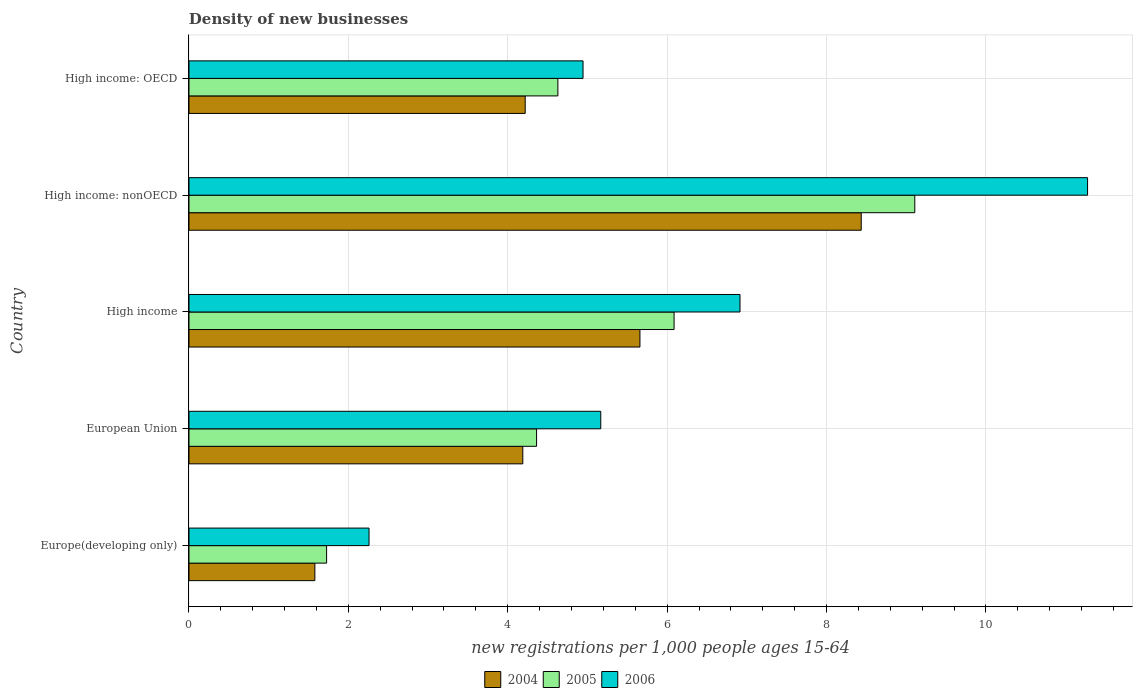How many different coloured bars are there?
Your answer should be compact. 3. Are the number of bars per tick equal to the number of legend labels?
Your answer should be very brief. Yes. Are the number of bars on each tick of the Y-axis equal?
Provide a succinct answer. Yes. What is the number of new registrations in 2006 in Europe(developing only)?
Offer a terse response. 2.26. Across all countries, what is the maximum number of new registrations in 2006?
Your response must be concise. 11.28. Across all countries, what is the minimum number of new registrations in 2005?
Your response must be concise. 1.73. In which country was the number of new registrations in 2005 maximum?
Keep it short and to the point. High income: nonOECD. In which country was the number of new registrations in 2004 minimum?
Your answer should be very brief. Europe(developing only). What is the total number of new registrations in 2005 in the graph?
Offer a terse response. 25.91. What is the difference between the number of new registrations in 2004 in High income and that in High income: OECD?
Provide a short and direct response. 1.44. What is the difference between the number of new registrations in 2004 in High income: OECD and the number of new registrations in 2006 in Europe(developing only)?
Your response must be concise. 1.96. What is the average number of new registrations in 2004 per country?
Your answer should be very brief. 4.82. What is the difference between the number of new registrations in 2005 and number of new registrations in 2004 in Europe(developing only)?
Offer a very short reply. 0.15. In how many countries, is the number of new registrations in 2006 greater than 0.8 ?
Make the answer very short. 5. What is the ratio of the number of new registrations in 2005 in European Union to that in High income?
Your answer should be very brief. 0.72. Is the number of new registrations in 2005 in Europe(developing only) less than that in European Union?
Make the answer very short. Yes. Is the difference between the number of new registrations in 2005 in High income: OECD and High income: nonOECD greater than the difference between the number of new registrations in 2004 in High income: OECD and High income: nonOECD?
Provide a succinct answer. No. What is the difference between the highest and the second highest number of new registrations in 2004?
Give a very brief answer. 2.78. What is the difference between the highest and the lowest number of new registrations in 2006?
Your answer should be very brief. 9.02. Is the sum of the number of new registrations in 2004 in High income and High income: OECD greater than the maximum number of new registrations in 2006 across all countries?
Offer a terse response. No. How many countries are there in the graph?
Your answer should be very brief. 5. What is the difference between two consecutive major ticks on the X-axis?
Ensure brevity in your answer.  2. Does the graph contain any zero values?
Offer a terse response. No. What is the title of the graph?
Give a very brief answer. Density of new businesses. Does "1971" appear as one of the legend labels in the graph?
Provide a succinct answer. No. What is the label or title of the X-axis?
Your answer should be compact. New registrations per 1,0 people ages 15-64. What is the label or title of the Y-axis?
Your response must be concise. Country. What is the new registrations per 1,000 people ages 15-64 of 2004 in Europe(developing only)?
Your answer should be very brief. 1.58. What is the new registrations per 1,000 people ages 15-64 in 2005 in Europe(developing only)?
Your response must be concise. 1.73. What is the new registrations per 1,000 people ages 15-64 of 2006 in Europe(developing only)?
Your answer should be compact. 2.26. What is the new registrations per 1,000 people ages 15-64 of 2004 in European Union?
Provide a short and direct response. 4.19. What is the new registrations per 1,000 people ages 15-64 of 2005 in European Union?
Ensure brevity in your answer.  4.36. What is the new registrations per 1,000 people ages 15-64 in 2006 in European Union?
Make the answer very short. 5.17. What is the new registrations per 1,000 people ages 15-64 of 2004 in High income?
Your answer should be compact. 5.66. What is the new registrations per 1,000 people ages 15-64 in 2005 in High income?
Provide a succinct answer. 6.09. What is the new registrations per 1,000 people ages 15-64 of 2006 in High income?
Your answer should be very brief. 6.91. What is the new registrations per 1,000 people ages 15-64 in 2004 in High income: nonOECD?
Offer a terse response. 8.44. What is the new registrations per 1,000 people ages 15-64 of 2005 in High income: nonOECD?
Give a very brief answer. 9.11. What is the new registrations per 1,000 people ages 15-64 of 2006 in High income: nonOECD?
Make the answer very short. 11.28. What is the new registrations per 1,000 people ages 15-64 of 2004 in High income: OECD?
Provide a succinct answer. 4.22. What is the new registrations per 1,000 people ages 15-64 in 2005 in High income: OECD?
Give a very brief answer. 4.63. What is the new registrations per 1,000 people ages 15-64 of 2006 in High income: OECD?
Your answer should be compact. 4.94. Across all countries, what is the maximum new registrations per 1,000 people ages 15-64 in 2004?
Offer a terse response. 8.44. Across all countries, what is the maximum new registrations per 1,000 people ages 15-64 of 2005?
Make the answer very short. 9.11. Across all countries, what is the maximum new registrations per 1,000 people ages 15-64 in 2006?
Give a very brief answer. 11.28. Across all countries, what is the minimum new registrations per 1,000 people ages 15-64 of 2004?
Offer a terse response. 1.58. Across all countries, what is the minimum new registrations per 1,000 people ages 15-64 in 2005?
Make the answer very short. 1.73. Across all countries, what is the minimum new registrations per 1,000 people ages 15-64 of 2006?
Offer a terse response. 2.26. What is the total new registrations per 1,000 people ages 15-64 of 2004 in the graph?
Give a very brief answer. 24.08. What is the total new registrations per 1,000 people ages 15-64 of 2005 in the graph?
Provide a succinct answer. 25.91. What is the total new registrations per 1,000 people ages 15-64 in 2006 in the graph?
Give a very brief answer. 30.56. What is the difference between the new registrations per 1,000 people ages 15-64 of 2004 in Europe(developing only) and that in European Union?
Give a very brief answer. -2.61. What is the difference between the new registrations per 1,000 people ages 15-64 of 2005 in Europe(developing only) and that in European Union?
Provide a short and direct response. -2.64. What is the difference between the new registrations per 1,000 people ages 15-64 of 2006 in Europe(developing only) and that in European Union?
Give a very brief answer. -2.91. What is the difference between the new registrations per 1,000 people ages 15-64 in 2004 in Europe(developing only) and that in High income?
Provide a succinct answer. -4.08. What is the difference between the new registrations per 1,000 people ages 15-64 in 2005 in Europe(developing only) and that in High income?
Provide a short and direct response. -4.36. What is the difference between the new registrations per 1,000 people ages 15-64 in 2006 in Europe(developing only) and that in High income?
Make the answer very short. -4.66. What is the difference between the new registrations per 1,000 people ages 15-64 in 2004 in Europe(developing only) and that in High income: nonOECD?
Your response must be concise. -6.86. What is the difference between the new registrations per 1,000 people ages 15-64 in 2005 in Europe(developing only) and that in High income: nonOECD?
Give a very brief answer. -7.38. What is the difference between the new registrations per 1,000 people ages 15-64 in 2006 in Europe(developing only) and that in High income: nonOECD?
Ensure brevity in your answer.  -9.02. What is the difference between the new registrations per 1,000 people ages 15-64 of 2004 in Europe(developing only) and that in High income: OECD?
Offer a very short reply. -2.64. What is the difference between the new registrations per 1,000 people ages 15-64 of 2005 in Europe(developing only) and that in High income: OECD?
Make the answer very short. -2.9. What is the difference between the new registrations per 1,000 people ages 15-64 of 2006 in Europe(developing only) and that in High income: OECD?
Your answer should be compact. -2.69. What is the difference between the new registrations per 1,000 people ages 15-64 of 2004 in European Union and that in High income?
Make the answer very short. -1.47. What is the difference between the new registrations per 1,000 people ages 15-64 of 2005 in European Union and that in High income?
Make the answer very short. -1.73. What is the difference between the new registrations per 1,000 people ages 15-64 of 2006 in European Union and that in High income?
Your response must be concise. -1.75. What is the difference between the new registrations per 1,000 people ages 15-64 in 2004 in European Union and that in High income: nonOECD?
Give a very brief answer. -4.25. What is the difference between the new registrations per 1,000 people ages 15-64 of 2005 in European Union and that in High income: nonOECD?
Your answer should be compact. -4.75. What is the difference between the new registrations per 1,000 people ages 15-64 of 2006 in European Union and that in High income: nonOECD?
Offer a terse response. -6.11. What is the difference between the new registrations per 1,000 people ages 15-64 in 2004 in European Union and that in High income: OECD?
Make the answer very short. -0.03. What is the difference between the new registrations per 1,000 people ages 15-64 in 2005 in European Union and that in High income: OECD?
Offer a terse response. -0.27. What is the difference between the new registrations per 1,000 people ages 15-64 of 2006 in European Union and that in High income: OECD?
Provide a short and direct response. 0.22. What is the difference between the new registrations per 1,000 people ages 15-64 in 2004 in High income and that in High income: nonOECD?
Make the answer very short. -2.78. What is the difference between the new registrations per 1,000 people ages 15-64 of 2005 in High income and that in High income: nonOECD?
Offer a terse response. -3.02. What is the difference between the new registrations per 1,000 people ages 15-64 of 2006 in High income and that in High income: nonOECD?
Provide a succinct answer. -4.36. What is the difference between the new registrations per 1,000 people ages 15-64 in 2004 in High income and that in High income: OECD?
Offer a very short reply. 1.44. What is the difference between the new registrations per 1,000 people ages 15-64 of 2005 in High income and that in High income: OECD?
Provide a succinct answer. 1.46. What is the difference between the new registrations per 1,000 people ages 15-64 in 2006 in High income and that in High income: OECD?
Your answer should be compact. 1.97. What is the difference between the new registrations per 1,000 people ages 15-64 of 2004 in High income: nonOECD and that in High income: OECD?
Offer a very short reply. 4.22. What is the difference between the new registrations per 1,000 people ages 15-64 of 2005 in High income: nonOECD and that in High income: OECD?
Offer a terse response. 4.48. What is the difference between the new registrations per 1,000 people ages 15-64 of 2006 in High income: nonOECD and that in High income: OECD?
Keep it short and to the point. 6.33. What is the difference between the new registrations per 1,000 people ages 15-64 in 2004 in Europe(developing only) and the new registrations per 1,000 people ages 15-64 in 2005 in European Union?
Your response must be concise. -2.78. What is the difference between the new registrations per 1,000 people ages 15-64 of 2004 in Europe(developing only) and the new registrations per 1,000 people ages 15-64 of 2006 in European Union?
Your response must be concise. -3.59. What is the difference between the new registrations per 1,000 people ages 15-64 of 2005 in Europe(developing only) and the new registrations per 1,000 people ages 15-64 of 2006 in European Union?
Your response must be concise. -3.44. What is the difference between the new registrations per 1,000 people ages 15-64 of 2004 in Europe(developing only) and the new registrations per 1,000 people ages 15-64 of 2005 in High income?
Provide a short and direct response. -4.51. What is the difference between the new registrations per 1,000 people ages 15-64 in 2004 in Europe(developing only) and the new registrations per 1,000 people ages 15-64 in 2006 in High income?
Ensure brevity in your answer.  -5.33. What is the difference between the new registrations per 1,000 people ages 15-64 of 2005 in Europe(developing only) and the new registrations per 1,000 people ages 15-64 of 2006 in High income?
Offer a very short reply. -5.19. What is the difference between the new registrations per 1,000 people ages 15-64 of 2004 in Europe(developing only) and the new registrations per 1,000 people ages 15-64 of 2005 in High income: nonOECD?
Your answer should be compact. -7.53. What is the difference between the new registrations per 1,000 people ages 15-64 of 2004 in Europe(developing only) and the new registrations per 1,000 people ages 15-64 of 2006 in High income: nonOECD?
Offer a terse response. -9.7. What is the difference between the new registrations per 1,000 people ages 15-64 of 2005 in Europe(developing only) and the new registrations per 1,000 people ages 15-64 of 2006 in High income: nonOECD?
Provide a succinct answer. -9.55. What is the difference between the new registrations per 1,000 people ages 15-64 in 2004 in Europe(developing only) and the new registrations per 1,000 people ages 15-64 in 2005 in High income: OECD?
Give a very brief answer. -3.05. What is the difference between the new registrations per 1,000 people ages 15-64 of 2004 in Europe(developing only) and the new registrations per 1,000 people ages 15-64 of 2006 in High income: OECD?
Your response must be concise. -3.37. What is the difference between the new registrations per 1,000 people ages 15-64 of 2005 in Europe(developing only) and the new registrations per 1,000 people ages 15-64 of 2006 in High income: OECD?
Ensure brevity in your answer.  -3.22. What is the difference between the new registrations per 1,000 people ages 15-64 of 2004 in European Union and the new registrations per 1,000 people ages 15-64 of 2005 in High income?
Make the answer very short. -1.9. What is the difference between the new registrations per 1,000 people ages 15-64 of 2004 in European Union and the new registrations per 1,000 people ages 15-64 of 2006 in High income?
Your response must be concise. -2.73. What is the difference between the new registrations per 1,000 people ages 15-64 of 2005 in European Union and the new registrations per 1,000 people ages 15-64 of 2006 in High income?
Give a very brief answer. -2.55. What is the difference between the new registrations per 1,000 people ages 15-64 of 2004 in European Union and the new registrations per 1,000 people ages 15-64 of 2005 in High income: nonOECD?
Your response must be concise. -4.92. What is the difference between the new registrations per 1,000 people ages 15-64 of 2004 in European Union and the new registrations per 1,000 people ages 15-64 of 2006 in High income: nonOECD?
Keep it short and to the point. -7.09. What is the difference between the new registrations per 1,000 people ages 15-64 of 2005 in European Union and the new registrations per 1,000 people ages 15-64 of 2006 in High income: nonOECD?
Provide a short and direct response. -6.91. What is the difference between the new registrations per 1,000 people ages 15-64 in 2004 in European Union and the new registrations per 1,000 people ages 15-64 in 2005 in High income: OECD?
Provide a succinct answer. -0.44. What is the difference between the new registrations per 1,000 people ages 15-64 in 2004 in European Union and the new registrations per 1,000 people ages 15-64 in 2006 in High income: OECD?
Your answer should be very brief. -0.76. What is the difference between the new registrations per 1,000 people ages 15-64 in 2005 in European Union and the new registrations per 1,000 people ages 15-64 in 2006 in High income: OECD?
Your response must be concise. -0.58. What is the difference between the new registrations per 1,000 people ages 15-64 of 2004 in High income and the new registrations per 1,000 people ages 15-64 of 2005 in High income: nonOECD?
Provide a succinct answer. -3.45. What is the difference between the new registrations per 1,000 people ages 15-64 in 2004 in High income and the new registrations per 1,000 people ages 15-64 in 2006 in High income: nonOECD?
Ensure brevity in your answer.  -5.62. What is the difference between the new registrations per 1,000 people ages 15-64 of 2005 in High income and the new registrations per 1,000 people ages 15-64 of 2006 in High income: nonOECD?
Keep it short and to the point. -5.19. What is the difference between the new registrations per 1,000 people ages 15-64 of 2004 in High income and the new registrations per 1,000 people ages 15-64 of 2005 in High income: OECD?
Your answer should be very brief. 1.03. What is the difference between the new registrations per 1,000 people ages 15-64 of 2004 in High income and the new registrations per 1,000 people ages 15-64 of 2006 in High income: OECD?
Ensure brevity in your answer.  0.71. What is the difference between the new registrations per 1,000 people ages 15-64 of 2005 in High income and the new registrations per 1,000 people ages 15-64 of 2006 in High income: OECD?
Provide a short and direct response. 1.14. What is the difference between the new registrations per 1,000 people ages 15-64 in 2004 in High income: nonOECD and the new registrations per 1,000 people ages 15-64 in 2005 in High income: OECD?
Make the answer very short. 3.81. What is the difference between the new registrations per 1,000 people ages 15-64 of 2004 in High income: nonOECD and the new registrations per 1,000 people ages 15-64 of 2006 in High income: OECD?
Ensure brevity in your answer.  3.49. What is the difference between the new registrations per 1,000 people ages 15-64 in 2005 in High income: nonOECD and the new registrations per 1,000 people ages 15-64 in 2006 in High income: OECD?
Make the answer very short. 4.16. What is the average new registrations per 1,000 people ages 15-64 in 2004 per country?
Give a very brief answer. 4.82. What is the average new registrations per 1,000 people ages 15-64 of 2005 per country?
Keep it short and to the point. 5.18. What is the average new registrations per 1,000 people ages 15-64 in 2006 per country?
Ensure brevity in your answer.  6.11. What is the difference between the new registrations per 1,000 people ages 15-64 of 2004 and new registrations per 1,000 people ages 15-64 of 2005 in Europe(developing only)?
Offer a terse response. -0.15. What is the difference between the new registrations per 1,000 people ages 15-64 in 2004 and new registrations per 1,000 people ages 15-64 in 2006 in Europe(developing only)?
Your response must be concise. -0.68. What is the difference between the new registrations per 1,000 people ages 15-64 of 2005 and new registrations per 1,000 people ages 15-64 of 2006 in Europe(developing only)?
Offer a terse response. -0.53. What is the difference between the new registrations per 1,000 people ages 15-64 of 2004 and new registrations per 1,000 people ages 15-64 of 2005 in European Union?
Keep it short and to the point. -0.17. What is the difference between the new registrations per 1,000 people ages 15-64 in 2004 and new registrations per 1,000 people ages 15-64 in 2006 in European Union?
Give a very brief answer. -0.98. What is the difference between the new registrations per 1,000 people ages 15-64 of 2005 and new registrations per 1,000 people ages 15-64 of 2006 in European Union?
Provide a succinct answer. -0.81. What is the difference between the new registrations per 1,000 people ages 15-64 in 2004 and new registrations per 1,000 people ages 15-64 in 2005 in High income?
Give a very brief answer. -0.43. What is the difference between the new registrations per 1,000 people ages 15-64 of 2004 and new registrations per 1,000 people ages 15-64 of 2006 in High income?
Your answer should be very brief. -1.26. What is the difference between the new registrations per 1,000 people ages 15-64 of 2005 and new registrations per 1,000 people ages 15-64 of 2006 in High income?
Your answer should be compact. -0.83. What is the difference between the new registrations per 1,000 people ages 15-64 in 2004 and new registrations per 1,000 people ages 15-64 in 2005 in High income: nonOECD?
Ensure brevity in your answer.  -0.67. What is the difference between the new registrations per 1,000 people ages 15-64 in 2004 and new registrations per 1,000 people ages 15-64 in 2006 in High income: nonOECD?
Offer a terse response. -2.84. What is the difference between the new registrations per 1,000 people ages 15-64 of 2005 and new registrations per 1,000 people ages 15-64 of 2006 in High income: nonOECD?
Make the answer very short. -2.17. What is the difference between the new registrations per 1,000 people ages 15-64 of 2004 and new registrations per 1,000 people ages 15-64 of 2005 in High income: OECD?
Provide a succinct answer. -0.41. What is the difference between the new registrations per 1,000 people ages 15-64 in 2004 and new registrations per 1,000 people ages 15-64 in 2006 in High income: OECD?
Your response must be concise. -0.73. What is the difference between the new registrations per 1,000 people ages 15-64 in 2005 and new registrations per 1,000 people ages 15-64 in 2006 in High income: OECD?
Offer a very short reply. -0.32. What is the ratio of the new registrations per 1,000 people ages 15-64 of 2004 in Europe(developing only) to that in European Union?
Ensure brevity in your answer.  0.38. What is the ratio of the new registrations per 1,000 people ages 15-64 in 2005 in Europe(developing only) to that in European Union?
Provide a succinct answer. 0.4. What is the ratio of the new registrations per 1,000 people ages 15-64 of 2006 in Europe(developing only) to that in European Union?
Keep it short and to the point. 0.44. What is the ratio of the new registrations per 1,000 people ages 15-64 in 2004 in Europe(developing only) to that in High income?
Provide a succinct answer. 0.28. What is the ratio of the new registrations per 1,000 people ages 15-64 in 2005 in Europe(developing only) to that in High income?
Keep it short and to the point. 0.28. What is the ratio of the new registrations per 1,000 people ages 15-64 of 2006 in Europe(developing only) to that in High income?
Offer a very short reply. 0.33. What is the ratio of the new registrations per 1,000 people ages 15-64 of 2004 in Europe(developing only) to that in High income: nonOECD?
Your response must be concise. 0.19. What is the ratio of the new registrations per 1,000 people ages 15-64 in 2005 in Europe(developing only) to that in High income: nonOECD?
Your answer should be compact. 0.19. What is the ratio of the new registrations per 1,000 people ages 15-64 in 2006 in Europe(developing only) to that in High income: nonOECD?
Ensure brevity in your answer.  0.2. What is the ratio of the new registrations per 1,000 people ages 15-64 in 2004 in Europe(developing only) to that in High income: OECD?
Offer a very short reply. 0.37. What is the ratio of the new registrations per 1,000 people ages 15-64 of 2005 in Europe(developing only) to that in High income: OECD?
Provide a succinct answer. 0.37. What is the ratio of the new registrations per 1,000 people ages 15-64 of 2006 in Europe(developing only) to that in High income: OECD?
Make the answer very short. 0.46. What is the ratio of the new registrations per 1,000 people ages 15-64 of 2004 in European Union to that in High income?
Make the answer very short. 0.74. What is the ratio of the new registrations per 1,000 people ages 15-64 in 2005 in European Union to that in High income?
Offer a very short reply. 0.72. What is the ratio of the new registrations per 1,000 people ages 15-64 of 2006 in European Union to that in High income?
Your answer should be compact. 0.75. What is the ratio of the new registrations per 1,000 people ages 15-64 of 2004 in European Union to that in High income: nonOECD?
Provide a short and direct response. 0.5. What is the ratio of the new registrations per 1,000 people ages 15-64 of 2005 in European Union to that in High income: nonOECD?
Make the answer very short. 0.48. What is the ratio of the new registrations per 1,000 people ages 15-64 of 2006 in European Union to that in High income: nonOECD?
Your answer should be compact. 0.46. What is the ratio of the new registrations per 1,000 people ages 15-64 of 2005 in European Union to that in High income: OECD?
Give a very brief answer. 0.94. What is the ratio of the new registrations per 1,000 people ages 15-64 in 2006 in European Union to that in High income: OECD?
Make the answer very short. 1.04. What is the ratio of the new registrations per 1,000 people ages 15-64 in 2004 in High income to that in High income: nonOECD?
Ensure brevity in your answer.  0.67. What is the ratio of the new registrations per 1,000 people ages 15-64 of 2005 in High income to that in High income: nonOECD?
Your response must be concise. 0.67. What is the ratio of the new registrations per 1,000 people ages 15-64 of 2006 in High income to that in High income: nonOECD?
Your answer should be compact. 0.61. What is the ratio of the new registrations per 1,000 people ages 15-64 in 2004 in High income to that in High income: OECD?
Keep it short and to the point. 1.34. What is the ratio of the new registrations per 1,000 people ages 15-64 of 2005 in High income to that in High income: OECD?
Keep it short and to the point. 1.31. What is the ratio of the new registrations per 1,000 people ages 15-64 in 2006 in High income to that in High income: OECD?
Provide a succinct answer. 1.4. What is the ratio of the new registrations per 1,000 people ages 15-64 of 2004 in High income: nonOECD to that in High income: OECD?
Provide a short and direct response. 2. What is the ratio of the new registrations per 1,000 people ages 15-64 of 2005 in High income: nonOECD to that in High income: OECD?
Your answer should be compact. 1.97. What is the ratio of the new registrations per 1,000 people ages 15-64 in 2006 in High income: nonOECD to that in High income: OECD?
Your answer should be very brief. 2.28. What is the difference between the highest and the second highest new registrations per 1,000 people ages 15-64 of 2004?
Provide a short and direct response. 2.78. What is the difference between the highest and the second highest new registrations per 1,000 people ages 15-64 of 2005?
Offer a very short reply. 3.02. What is the difference between the highest and the second highest new registrations per 1,000 people ages 15-64 in 2006?
Your answer should be compact. 4.36. What is the difference between the highest and the lowest new registrations per 1,000 people ages 15-64 in 2004?
Offer a very short reply. 6.86. What is the difference between the highest and the lowest new registrations per 1,000 people ages 15-64 in 2005?
Your answer should be very brief. 7.38. What is the difference between the highest and the lowest new registrations per 1,000 people ages 15-64 in 2006?
Your answer should be compact. 9.02. 